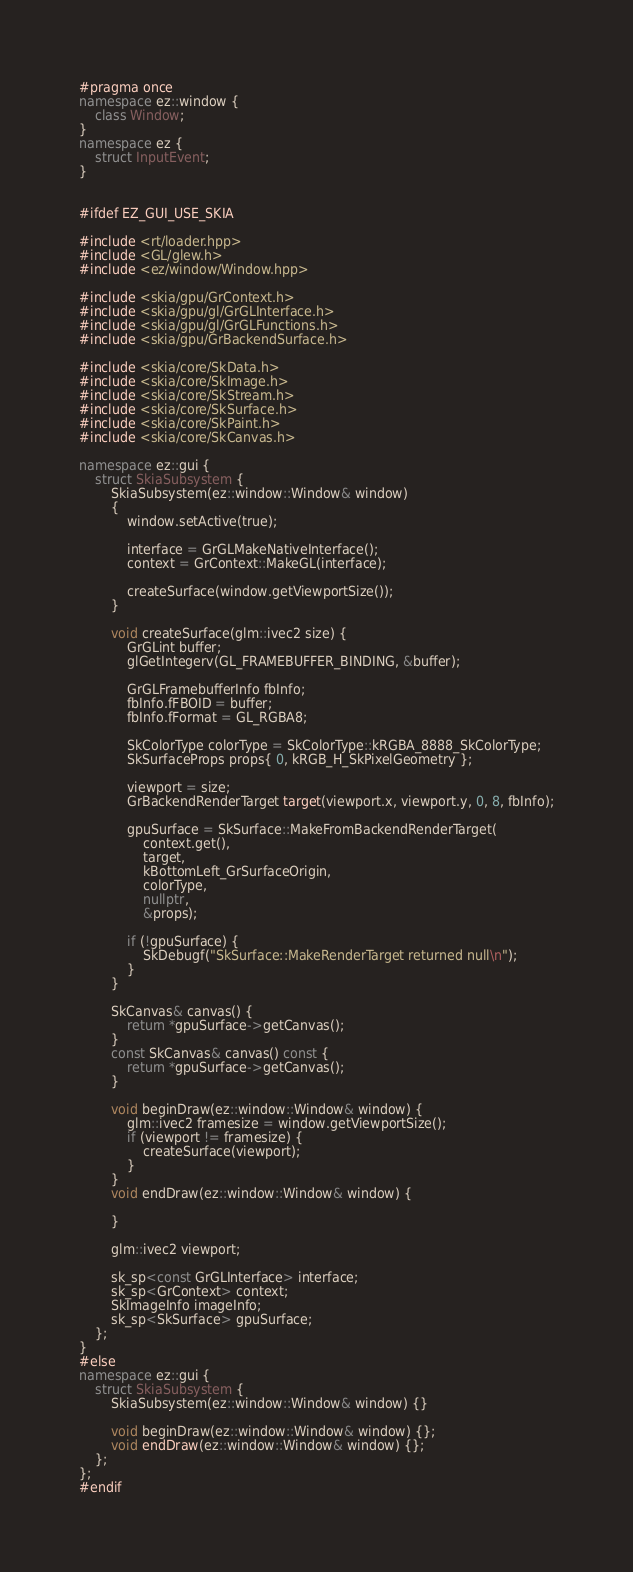Convert code to text. <code><loc_0><loc_0><loc_500><loc_500><_C++_>#pragma once
namespace ez::window {
	class Window;
}
namespace ez {
	struct InputEvent;
}


#ifdef EZ_GUI_USE_SKIA 

#include <rt/loader.hpp>
#include <GL/glew.h>
#include <ez/window/Window.hpp>

#include <skia/gpu/GrContext.h>
#include <skia/gpu/gl/GrGLInterface.h>
#include <skia/gpu/gl/GrGLFunctions.h>
#include <skia/gpu/GrBackendSurface.h>

#include <skia/core/SkData.h>
#include <skia/core/SkImage.h>
#include <skia/core/SkStream.h>
#include <skia/core/SkSurface.h>
#include <skia/core/SkPaint.h>
#include <skia/core/SkCanvas.h>

namespace ez::gui {
	struct SkiaSubsystem {
		SkiaSubsystem(ez::window::Window& window) 
		{
			window.setActive(true);

			interface = GrGLMakeNativeInterface();
			context = GrContext::MakeGL(interface);

			createSurface(window.getViewportSize());
		}

		void createSurface(glm::ivec2 size) {
			GrGLint buffer;
			glGetIntegerv(GL_FRAMEBUFFER_BINDING, &buffer);

			GrGLFramebufferInfo fbInfo;
			fbInfo.fFBOID = buffer;
			fbInfo.fFormat = GL_RGBA8;

			SkColorType colorType = SkColorType::kRGBA_8888_SkColorType;
			SkSurfaceProps props{ 0, kRGB_H_SkPixelGeometry };

			viewport = size;
			GrBackendRenderTarget target(viewport.x, viewport.y, 0, 8, fbInfo);

			gpuSurface = SkSurface::MakeFromBackendRenderTarget(
				context.get(),
				target,
				kBottomLeft_GrSurfaceOrigin,
				colorType,
				nullptr,
				&props);

			if (!gpuSurface) {
				SkDebugf("SkSurface::MakeRenderTarget returned null\n");
			}
		}

		SkCanvas& canvas() {
			return *gpuSurface->getCanvas();
		}
		const SkCanvas& canvas() const {
			return *gpuSurface->getCanvas();
		}

		void beginDraw(ez::window::Window& window) {
			glm::ivec2 framesize = window.getViewportSize();
			if (viewport != framesize) {
				createSurface(viewport);
			}
		}
		void endDraw(ez::window::Window& window) {

		}

		glm::ivec2 viewport;

		sk_sp<const GrGLInterface> interface;
		sk_sp<GrContext> context;
		SkImageInfo imageInfo;
		sk_sp<SkSurface> gpuSurface;
	};
}
#else
namespace ez::gui {
	struct SkiaSubsystem {
		SkiaSubsystem(ez::window::Window& window) {}

		void beginDraw(ez::window::Window& window) {};
		void endDraw(ez::window::Window& window) {};
	};
};
#endif
</code> 